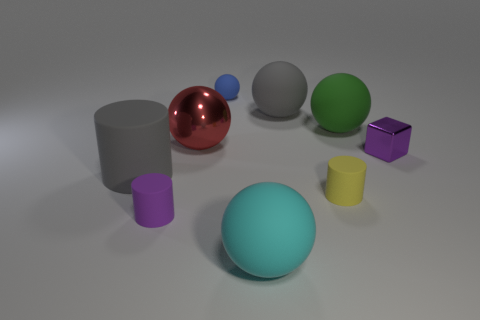Does the small rubber ball have the same color as the small object that is left of the red metallic thing?
Provide a succinct answer. No. The big gray thing that is on the right side of the gray cylinder has what shape?
Offer a very short reply. Sphere. What number of other objects are the same material as the tiny blue thing?
Keep it short and to the point. 6. What is the material of the yellow cylinder?
Your response must be concise. Rubber. How many tiny objects are either metal objects or yellow cylinders?
Offer a very short reply. 2. There is a red thing; what number of purple cylinders are behind it?
Ensure brevity in your answer.  0. Is there a tiny matte cylinder of the same color as the shiny cube?
Provide a short and direct response. Yes. There is a cyan matte object that is the same size as the red object; what shape is it?
Give a very brief answer. Sphere. What number of purple objects are cylinders or big metal objects?
Provide a succinct answer. 1. How many cubes are the same size as the yellow matte cylinder?
Give a very brief answer. 1. 